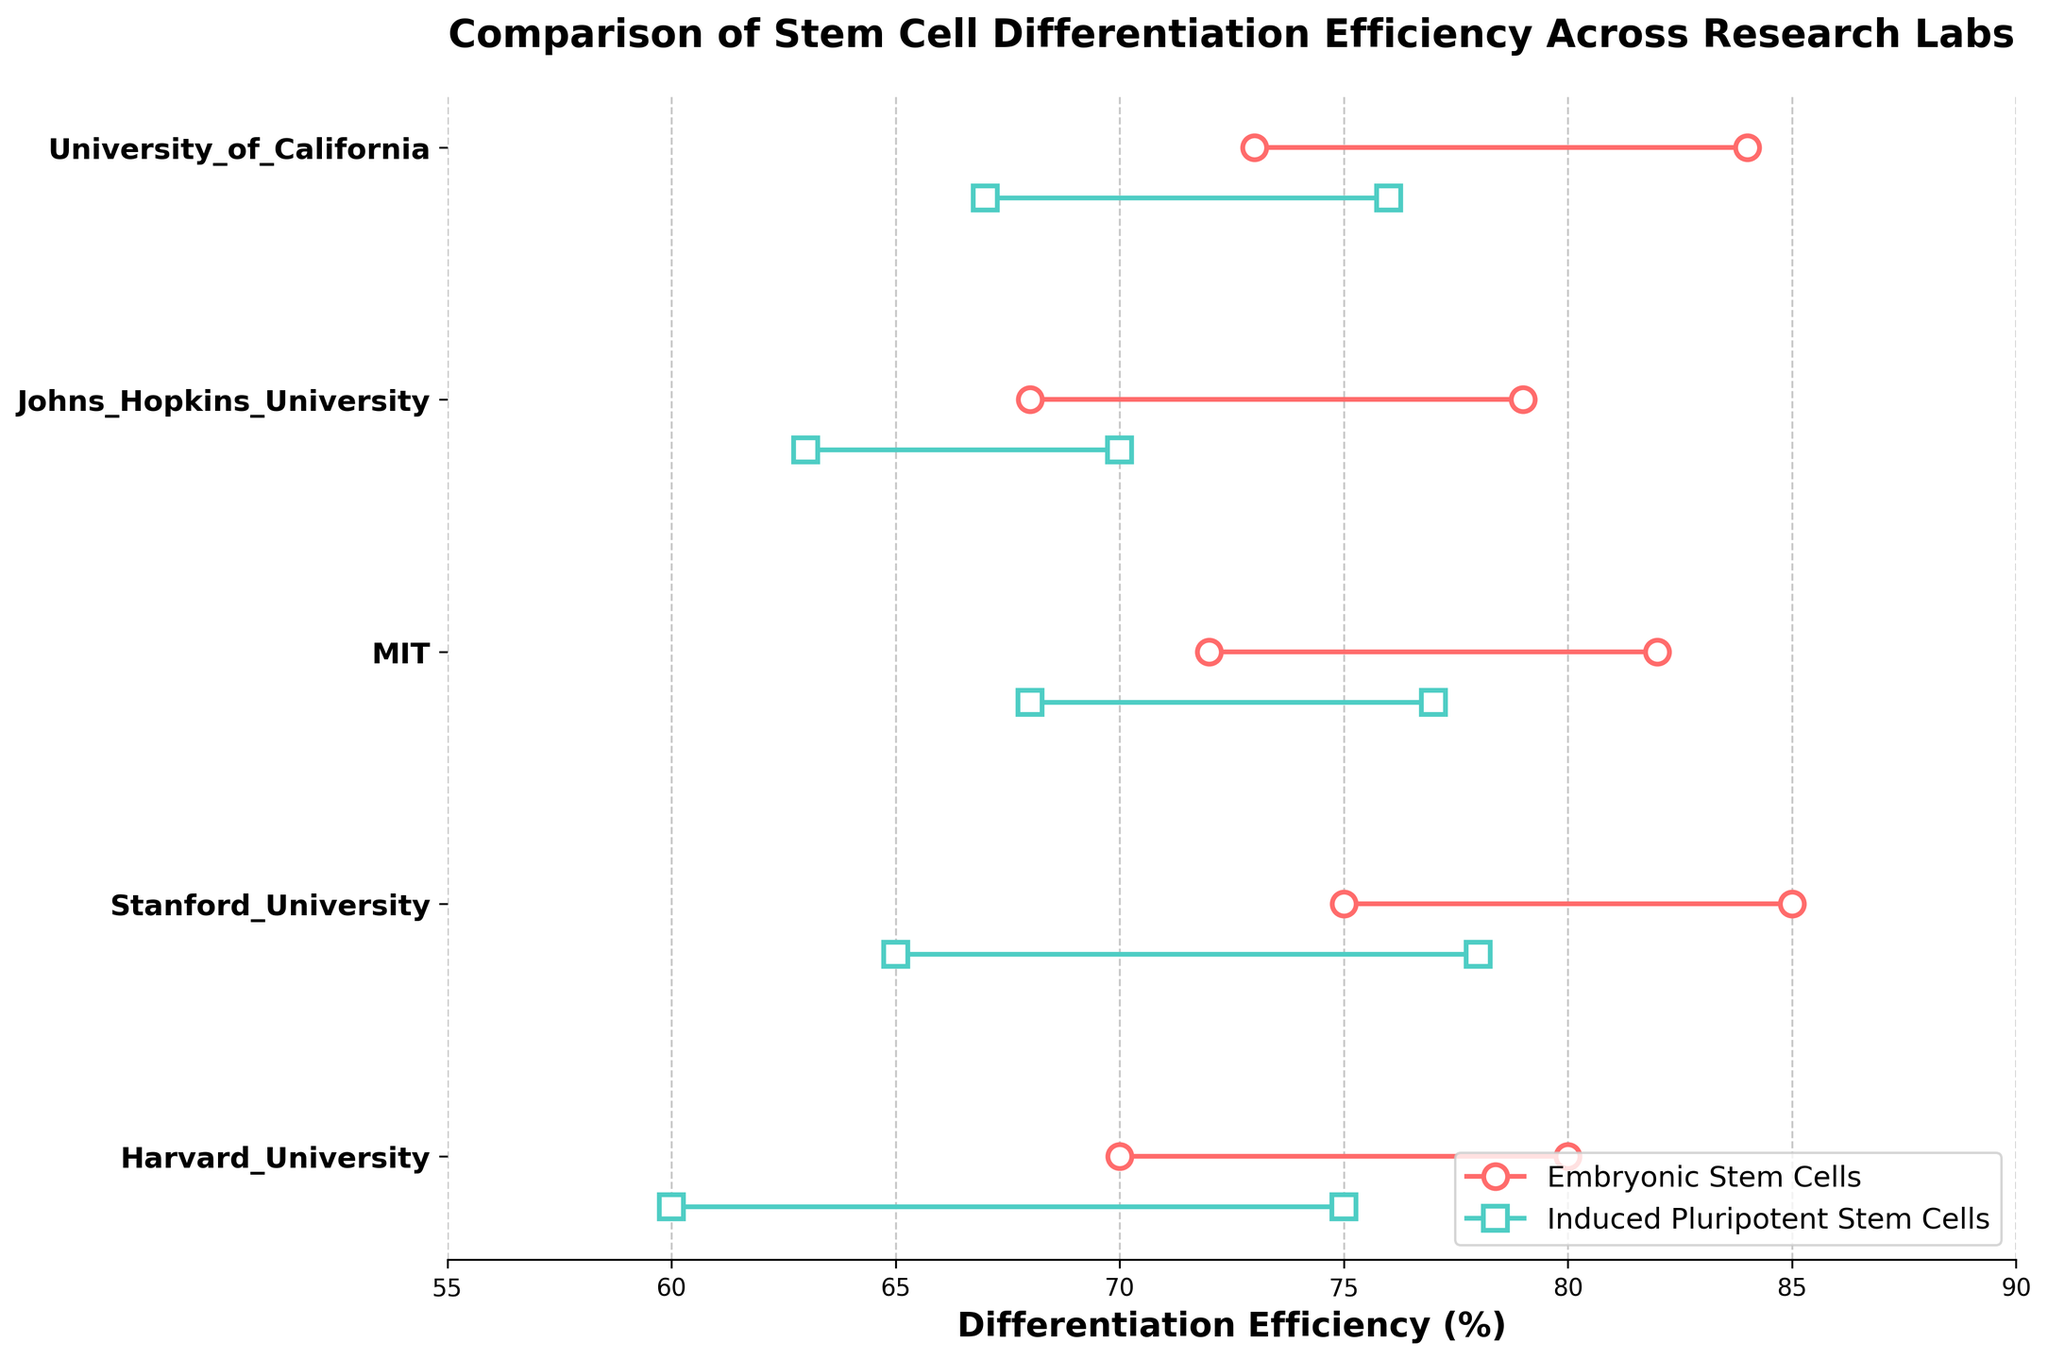Which lab has the highest differentiation efficiency range for embryonic stem cells? First, identify the differentiation efficiency ranges for embryonic stem cells for each lab. Harvard has 70-80%, Stanford has 75-85%, MIT has 72-82%, Johns Hopkins has 68-79%, and University of California has 73-84%. Stanford University has the highest range with 75-85%.
Answer: Stanford University Which lab has the smallest differentiation efficiency range for induced pluripotent stem cells? Identify the differentiation efficiency ranges for induced pluripotent stem cells for each lab. Harvard has 60-75%, Stanford has 65-78%, MIT has 68-77%, Johns Hopkins has 63-70%, and University of California has 67-76%. Johns Hopkins University has the smallest range with 63-70%.
Answer: Johns Hopkins University What is the average high differentiation efficiency for embryonic stem cells across all labs? Sum the high efficiencies for embryonic stem cells from all labs: (80 + 85 + 82 + 79 + 84 = 410). Divide by the number of labs (5): 410 / 5 = 82%.
Answer: 82% How much higher is the high differentiation efficiency for embryonic stem cells at Stanford compared to Johns Hopkins? Stanford's high efficiency for embryonic stem cells is 85%, and Johns Hopkins' is 79%. Subtract Johns Hopkins' value from Stanford's: 85 - 79 = 6%.
Answer: 6% What's the difference between the low differentiation efficiency of induced pluripotent stem cells and embryonic stem cells at Harvard? Harvard's low efficiency for induced pluripotent stem cells is 60% and for embryonic stem cells is 70%. Subtract the lower value from the higher one: 70 - 60 = 10%.
Answer: 10% Which stem cell type shows a larger range of differentiation efficiency at MIT? MIT's embryonic stem cells have a range of 72-82% (10%), and induced pluripotent stem cells have a range of 68-77% (9%). Therefore, embryonic stem cells show a larger range.
Answer: Embryonic Stem Cells What is the difference in high differentiation efficiency between embryonic stem cells and induced pluripotent stem cells at University of California? The high efficiency for embryonic stem cells at University of California is 84%, and for induced pluripotent stem cells, it’s 76%. Subtract the lower value from the higher one: 84 - 76 = 8%.
Answer: 8% Is there any lab where induced pluripotent stem cells have a higher high efficiency than embryonic stem cells? By checking each lab, we see that in every case, embryonic stem cells have a higher high efficiency than induced pluripotent stem cells. Therefore, the answer is no.
Answer: No Which university has the highest low differentiation efficiency for induced pluripotent stem cells? For low differentiation efficiency of induced pluripotent stem cells, check each university. Harvard has 60%, Stanford has 65%, MIT has 68%, Johns Hopkins has 63%, and University of California has 67%. MIT has the highest low differentiation efficiency with 68%.
Answer: MIT What's the combined range of differentiation efficiencies for both stem cell types at Stanford University? Stanford's range for embryonic stem cells is 75-85% and for induced pluripotent stem cells is 65-78%. The combined range spans from the lowest low to the highest high: 65 (induced pluripotent stem cells) to 85 (embryonic stem cells), with a total range of 85 - 65 = 20%.
Answer: 20% 